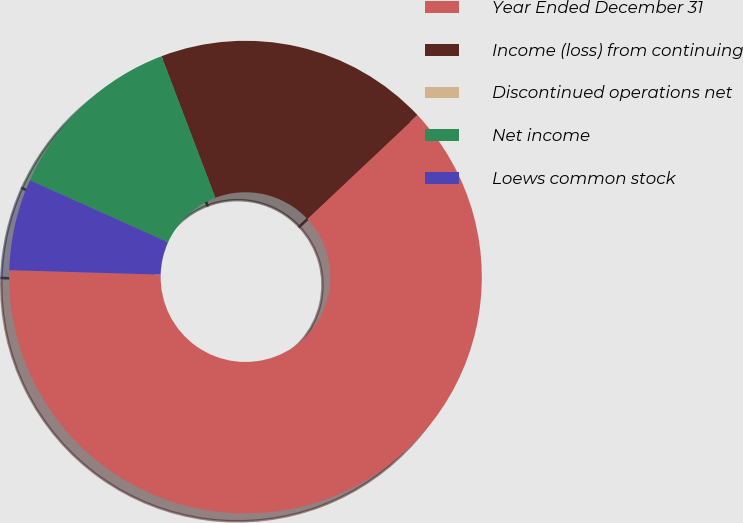Convert chart to OTSL. <chart><loc_0><loc_0><loc_500><loc_500><pie_chart><fcel>Year Ended December 31<fcel>Income (loss) from continuing<fcel>Discontinued operations net<fcel>Net income<fcel>Loews common stock<nl><fcel>62.5%<fcel>18.75%<fcel>0.0%<fcel>12.5%<fcel>6.25%<nl></chart> 